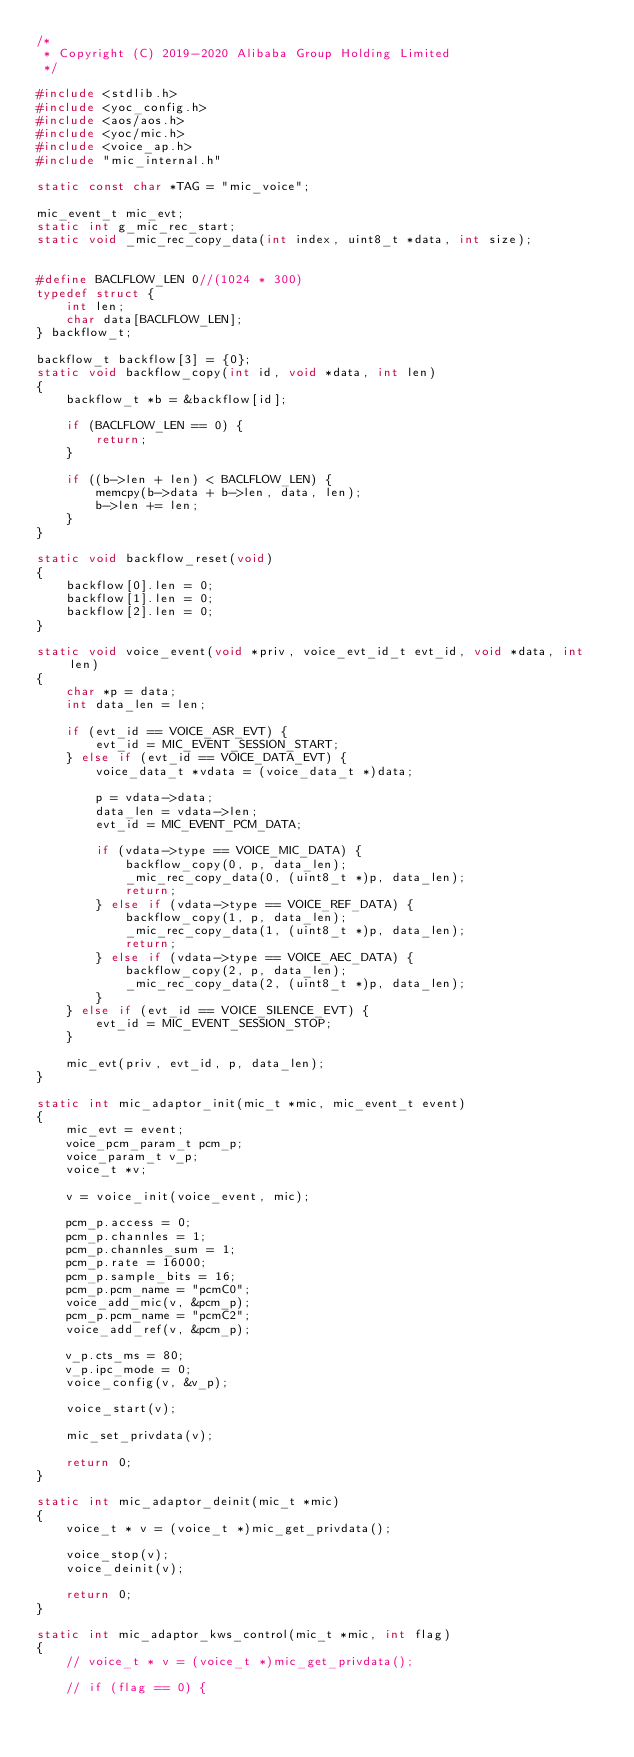Convert code to text. <code><loc_0><loc_0><loc_500><loc_500><_C_>/*
 * Copyright (C) 2019-2020 Alibaba Group Holding Limited
 */

#include <stdlib.h>
#include <yoc_config.h>
#include <aos/aos.h>
#include <yoc/mic.h>
#include <voice_ap.h>
#include "mic_internal.h"

static const char *TAG = "mic_voice";

mic_event_t mic_evt;
static int g_mic_rec_start;
static void _mic_rec_copy_data(int index, uint8_t *data, int size);


#define BACLFLOW_LEN 0//(1024 * 300)
typedef struct {
    int len;
    char data[BACLFLOW_LEN];
} backflow_t;

backflow_t backflow[3] = {0};
static void backflow_copy(int id, void *data, int len)
{
    backflow_t *b = &backflow[id];

    if (BACLFLOW_LEN == 0) {
        return;
    }

    if ((b->len + len) < BACLFLOW_LEN) {
        memcpy(b->data + b->len, data, len);
        b->len += len;
    }
}

static void backflow_reset(void)
{
    backflow[0].len = 0;
    backflow[1].len = 0;
    backflow[2].len = 0;
}

static void voice_event(void *priv, voice_evt_id_t evt_id, void *data, int len)
{
    char *p = data;
    int data_len = len;

    if (evt_id == VOICE_ASR_EVT) {
        evt_id = MIC_EVENT_SESSION_START;
    } else if (evt_id == VOICE_DATA_EVT) {
        voice_data_t *vdata = (voice_data_t *)data;

        p = vdata->data;
        data_len = vdata->len;
        evt_id = MIC_EVENT_PCM_DATA;

        if (vdata->type == VOICE_MIC_DATA) {
            backflow_copy(0, p, data_len);
            _mic_rec_copy_data(0, (uint8_t *)p, data_len);
            return;
        } else if (vdata->type == VOICE_REF_DATA) {
            backflow_copy(1, p, data_len);
            _mic_rec_copy_data(1, (uint8_t *)p, data_len);
            return;
        } else if (vdata->type == VOICE_AEC_DATA) {
            backflow_copy(2, p, data_len);
            _mic_rec_copy_data(2, (uint8_t *)p, data_len);
        }
    } else if (evt_id == VOICE_SILENCE_EVT) {
        evt_id = MIC_EVENT_SESSION_STOP;
    }

    mic_evt(priv, evt_id, p, data_len);
}

static int mic_adaptor_init(mic_t *mic, mic_event_t event)
{
    mic_evt = event;
    voice_pcm_param_t pcm_p;
    voice_param_t v_p;
    voice_t *v;

    v = voice_init(voice_event, mic);

    pcm_p.access = 0;
    pcm_p.channles = 1;
    pcm_p.channles_sum = 1;
    pcm_p.rate = 16000;
    pcm_p.sample_bits = 16;
    pcm_p.pcm_name = "pcmC0";
    voice_add_mic(v, &pcm_p);
    pcm_p.pcm_name = "pcmC2";
    voice_add_ref(v, &pcm_p);

    v_p.cts_ms = 80;
    v_p.ipc_mode = 0;
    voice_config(v, &v_p);

    voice_start(v);

    mic_set_privdata(v);

    return 0;
}

static int mic_adaptor_deinit(mic_t *mic)
{
    voice_t * v = (voice_t *)mic_get_privdata();

    voice_stop(v);
    voice_deinit(v);

    return 0;
}

static int mic_adaptor_kws_control(mic_t *mic, int flag)
{
    // voice_t * v = (voice_t *)mic_get_privdata();

    // if (flag == 0) {</code> 